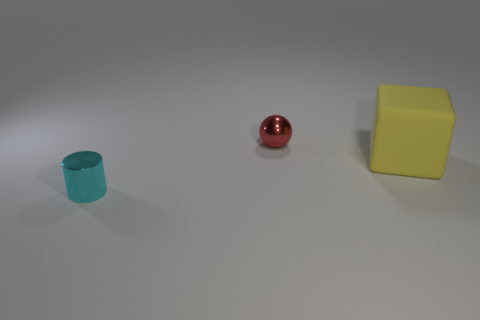What textures are present on the objects if any? The yellow cube and cyan cylinder appear to have a matte texture, while the red sphere has a shiny, reflective texture that can be seen by the light reflecting off its surface. 